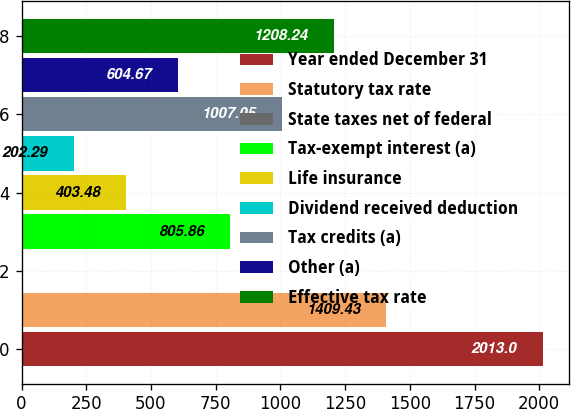<chart> <loc_0><loc_0><loc_500><loc_500><bar_chart><fcel>Year ended December 31<fcel>Statutory tax rate<fcel>State taxes net of federal<fcel>Tax-exempt interest (a)<fcel>Life insurance<fcel>Dividend received deduction<fcel>Tax credits (a)<fcel>Other (a)<fcel>Effective tax rate<nl><fcel>2013<fcel>1409.43<fcel>1.1<fcel>805.86<fcel>403.48<fcel>202.29<fcel>1007.05<fcel>604.67<fcel>1208.24<nl></chart> 